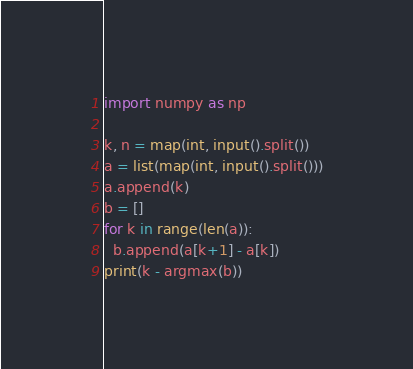Convert code to text. <code><loc_0><loc_0><loc_500><loc_500><_Python_>import numpy as np

k, n = map(int, input().split())
a = list(map(int, input().split()))
a.append(k)
b = []
for k in range(len(a)):
  b.append(a[k+1] - a[k])
print(k - argmax(b))</code> 